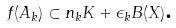Convert formula to latex. <formula><loc_0><loc_0><loc_500><loc_500>f ( A _ { k } ) \subset n _ { k } K + \epsilon _ { k } B ( X ) \text {.}</formula> 